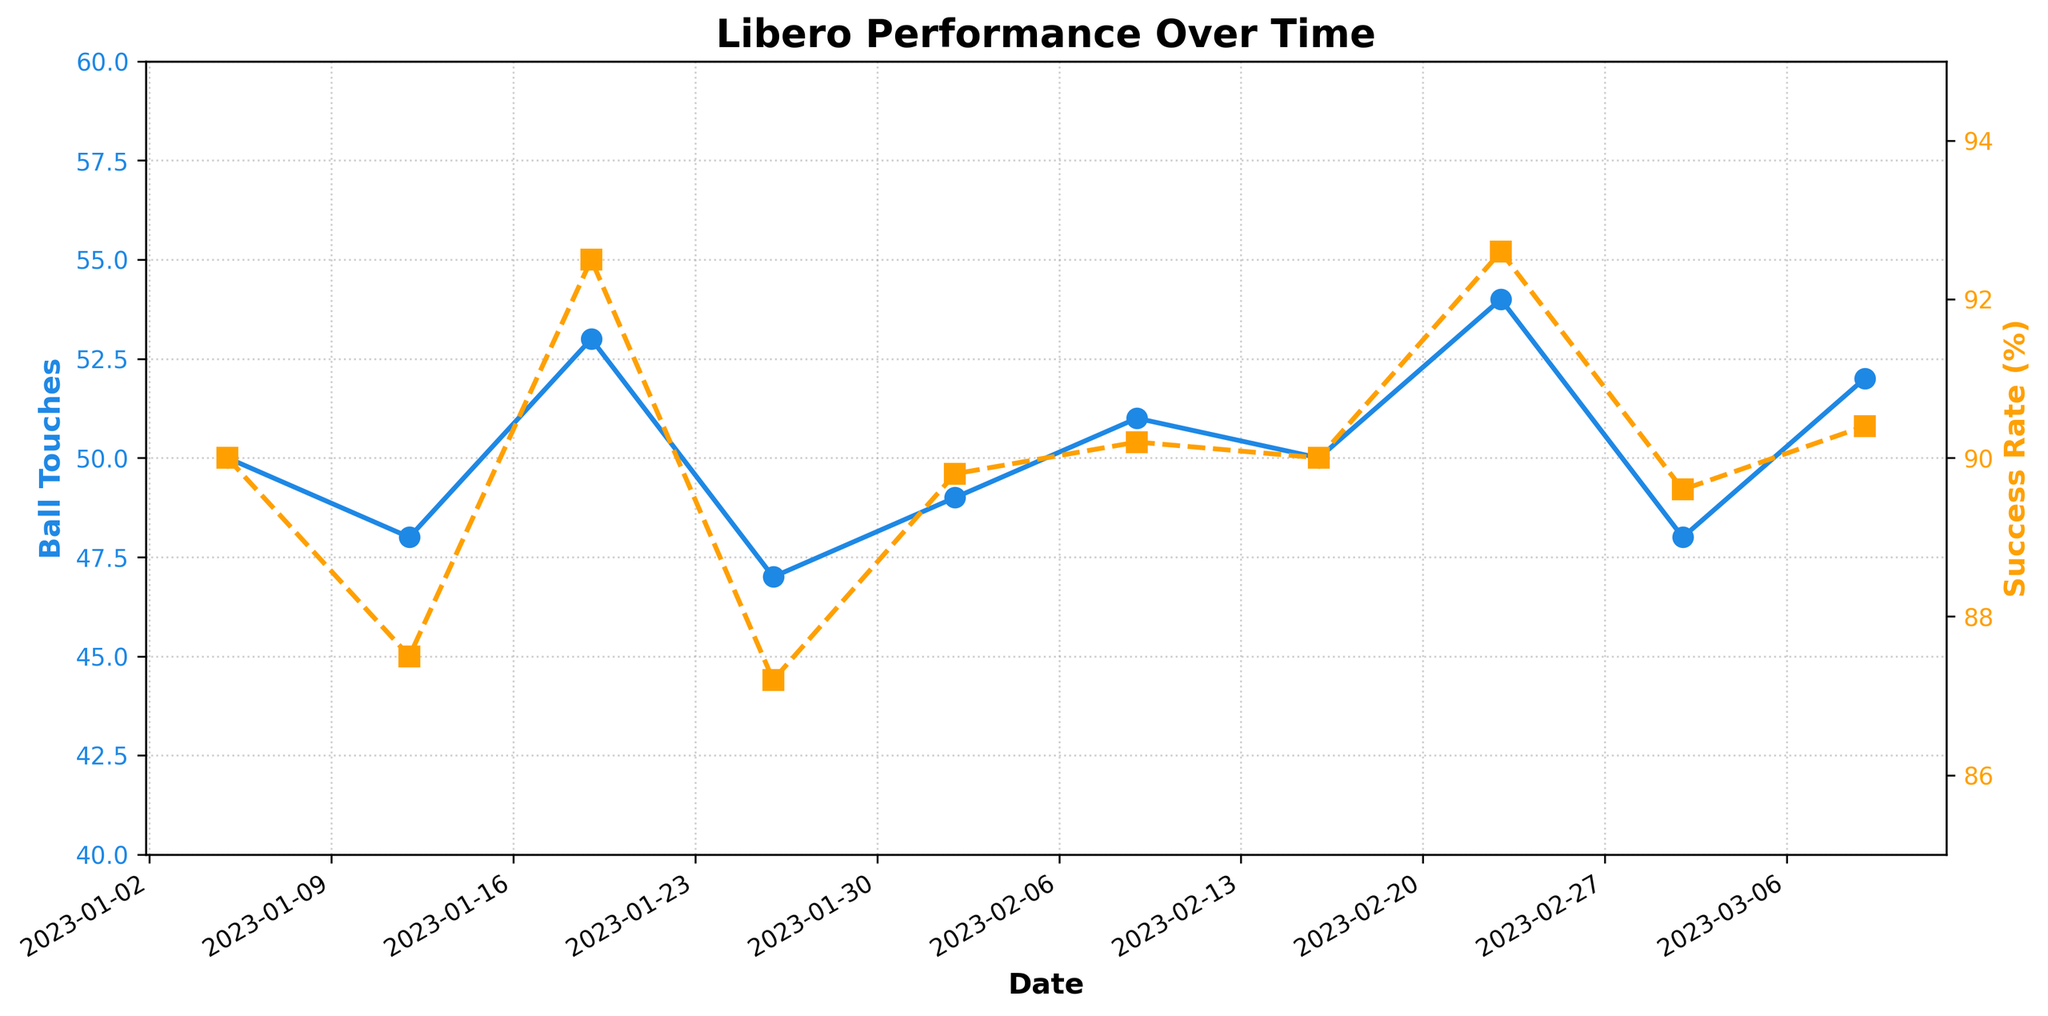What is the title of the figure? The title is at the top of the figure and provides an overview of what the data represents.
Answer: Libero Performance Over Time How many matches are shown in the figure? Each point on the x-axis corresponds to a match, and there are ten data points along the x-axis.
Answer: 10 What color represents Ball Touches on the plot? The Ball Touches data is plotted with markers and lines of a specific color.
Answer: Blue What was the Success Rate on 2023-02-23? Locate the data point for 2023-02-23 on the orange line (Success Rate) and read the y-axis value.
Answer: 92.6 What's the highest Success Rate achieved and in which match? Identify the peak point on the Success Rate (orange line) and check the corresponding match.
Answer: 92.6 in Match8 What is the average Ball Touches per match? Sum all the Ball Touches values and divide by the number of matches. (50+48+53+47+49+51+50+54+48+52)/10 = 50.2
Answer: 50.2 Compared to Ball Touches, how does the Success Rate trend look over time? Compare the general direction and fluctuations of both trends on the plot.
Answer: Both trend generally upward with some small fluctuations For which dates do Ball Touches and Success Rate both have the same trend direction (either both increasing or both decreasing)? Examine the trends between successive data points for Ball Touches and Success Rate and check where both lines increase or decrease together.
Answer: 2023-02-16, 2023-02-23 On which date(s) did Alex have exactly 50 Ball Touches? Look for the points on the blue Ball Touches line that equal 50 and note the corresponding dates.
Answer: 2023-01-05 and 2023-02-16 What is the maximum difference in Success Rate between two consecutive matches? Calculate the differences in Success Rate between each pair of consecutive matches and identify the maximum value. Max difference is between Match2 (87.5) and Match3 (92.5): 92.5 - 87.5 = 5.0
Answer: 5.0 